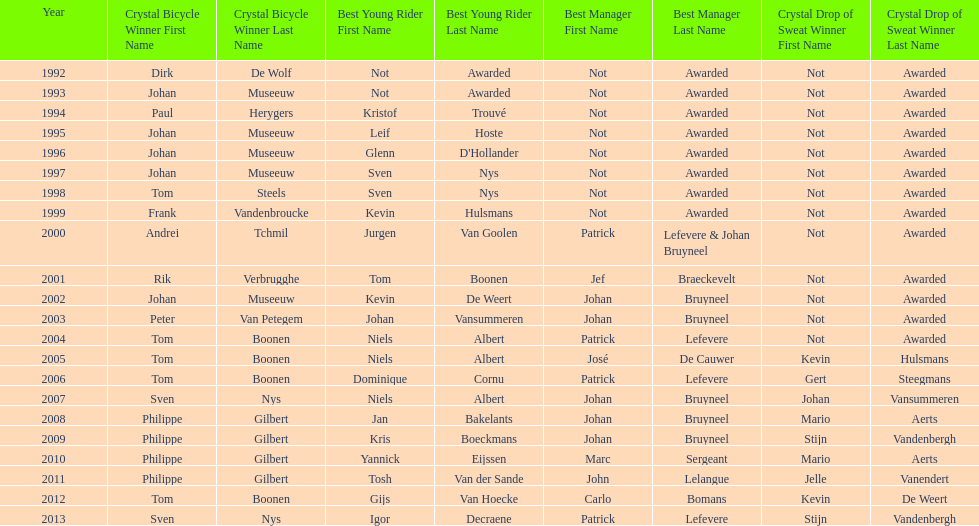What is the average number of times johan museeuw starred? 5. 